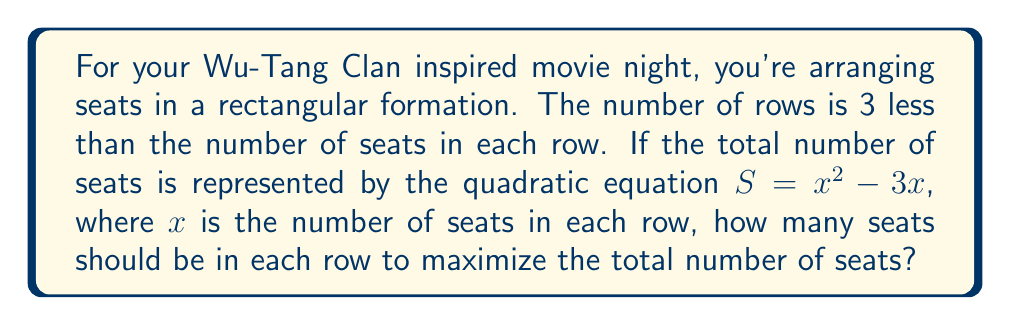Can you answer this question? Let's approach this step-by-step:

1) We're given that $S = x^2 - 3x$, where $S$ is the total number of seats and $x$ is the number of seats in each row.

2) To find the maximum value of $S$, we need to find the vertex of this parabola. The vertex represents the point where the function reaches its maximum value.

3) For a quadratic function in the form $f(x) = ax^2 + bx + c$, the x-coordinate of the vertex is given by $x = -\frac{b}{2a}$.

4) In our case, $a = 1$ and $b = -3$. So:

   $x = -\frac{(-3)}{2(1)} = \frac{3}{2}$

5) However, since we're dealing with seats, we need a whole number. We should check the two nearest integers: 1 and 2.

6) Let's calculate $S$ for both:
   For $x = 1$: $S = 1^2 - 3(1) = 1 - 3 = -2$
   For $x = 2$: $S = 2^2 - 3(2) = 4 - 6 = -2$

7) Both give the same result, but since we want to maximize seating, we choose the larger value of $x$.

Therefore, there should be 2 seats in each row to maximize the total number of seats.
Answer: 2 seats per row 